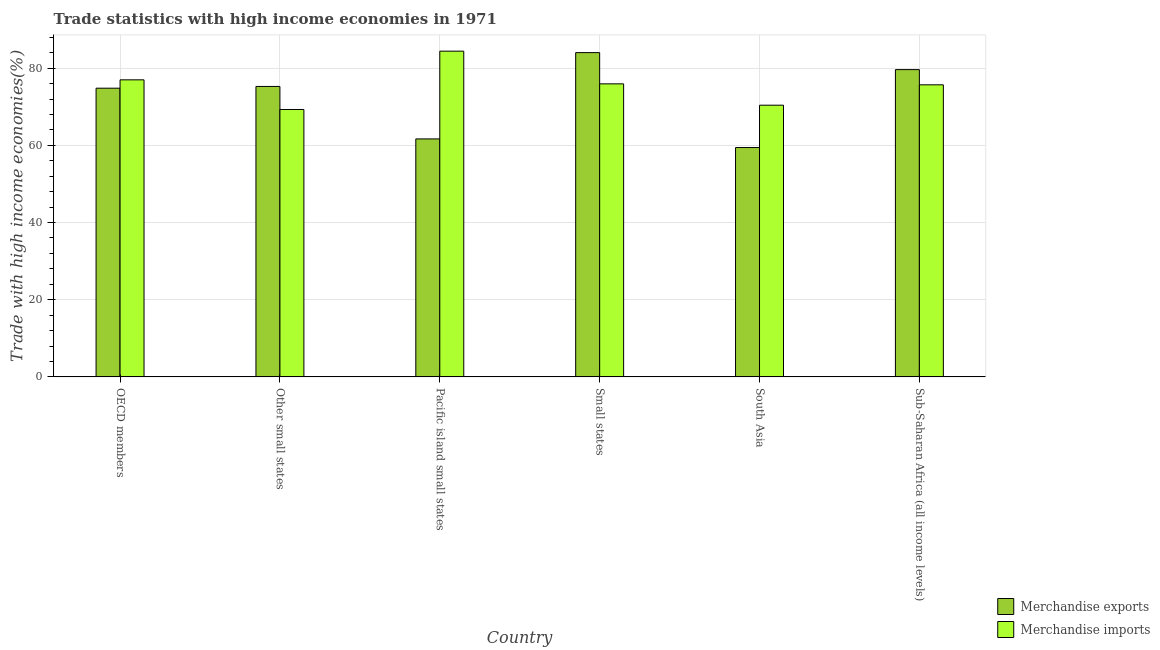Are the number of bars per tick equal to the number of legend labels?
Provide a succinct answer. Yes. Are the number of bars on each tick of the X-axis equal?
Provide a short and direct response. Yes. How many bars are there on the 4th tick from the left?
Make the answer very short. 2. What is the label of the 2nd group of bars from the left?
Offer a terse response. Other small states. In how many cases, is the number of bars for a given country not equal to the number of legend labels?
Offer a very short reply. 0. What is the merchandise exports in Other small states?
Provide a short and direct response. 75.28. Across all countries, what is the maximum merchandise imports?
Offer a very short reply. 84.42. Across all countries, what is the minimum merchandise imports?
Provide a succinct answer. 69.3. In which country was the merchandise imports maximum?
Offer a terse response. Pacific island small states. In which country was the merchandise imports minimum?
Provide a short and direct response. Other small states. What is the total merchandise exports in the graph?
Offer a very short reply. 434.9. What is the difference between the merchandise imports in OECD members and that in Other small states?
Provide a short and direct response. 7.69. What is the difference between the merchandise exports in Sub-Saharan Africa (all income levels) and the merchandise imports in Small states?
Offer a very short reply. 3.69. What is the average merchandise exports per country?
Give a very brief answer. 72.48. What is the difference between the merchandise exports and merchandise imports in Small states?
Provide a short and direct response. 8.1. In how many countries, is the merchandise imports greater than 52 %?
Give a very brief answer. 6. What is the ratio of the merchandise exports in Pacific island small states to that in South Asia?
Give a very brief answer. 1.04. Is the difference between the merchandise imports in Other small states and Small states greater than the difference between the merchandise exports in Other small states and Small states?
Provide a short and direct response. Yes. What is the difference between the highest and the second highest merchandise exports?
Your answer should be very brief. 4.41. What is the difference between the highest and the lowest merchandise exports?
Keep it short and to the point. 24.6. In how many countries, is the merchandise imports greater than the average merchandise imports taken over all countries?
Keep it short and to the point. 4. What does the 1st bar from the left in OECD members represents?
Your answer should be compact. Merchandise exports. What does the 2nd bar from the right in Sub-Saharan Africa (all income levels) represents?
Make the answer very short. Merchandise exports. Are all the bars in the graph horizontal?
Your answer should be compact. No. How many countries are there in the graph?
Offer a very short reply. 6. Does the graph contain any zero values?
Your answer should be compact. No. What is the title of the graph?
Offer a terse response. Trade statistics with high income economies in 1971. Does "Techinal cooperation" appear as one of the legend labels in the graph?
Your response must be concise. No. What is the label or title of the X-axis?
Make the answer very short. Country. What is the label or title of the Y-axis?
Provide a succinct answer. Trade with high income economies(%). What is the Trade with high income economies(%) in Merchandise exports in OECD members?
Offer a very short reply. 74.82. What is the Trade with high income economies(%) in Merchandise imports in OECD members?
Your answer should be compact. 76.99. What is the Trade with high income economies(%) of Merchandise exports in Other small states?
Offer a very short reply. 75.28. What is the Trade with high income economies(%) of Merchandise imports in Other small states?
Keep it short and to the point. 69.3. What is the Trade with high income economies(%) in Merchandise exports in Pacific island small states?
Ensure brevity in your answer.  61.68. What is the Trade with high income economies(%) in Merchandise imports in Pacific island small states?
Your answer should be very brief. 84.42. What is the Trade with high income economies(%) in Merchandise exports in Small states?
Provide a succinct answer. 84.04. What is the Trade with high income economies(%) in Merchandise imports in Small states?
Give a very brief answer. 75.95. What is the Trade with high income economies(%) in Merchandise exports in South Asia?
Your response must be concise. 59.44. What is the Trade with high income economies(%) of Merchandise imports in South Asia?
Give a very brief answer. 70.42. What is the Trade with high income economies(%) of Merchandise exports in Sub-Saharan Africa (all income levels)?
Provide a short and direct response. 79.64. What is the Trade with high income economies(%) of Merchandise imports in Sub-Saharan Africa (all income levels)?
Keep it short and to the point. 75.7. Across all countries, what is the maximum Trade with high income economies(%) in Merchandise exports?
Ensure brevity in your answer.  84.04. Across all countries, what is the maximum Trade with high income economies(%) in Merchandise imports?
Make the answer very short. 84.42. Across all countries, what is the minimum Trade with high income economies(%) of Merchandise exports?
Your answer should be very brief. 59.44. Across all countries, what is the minimum Trade with high income economies(%) of Merchandise imports?
Offer a very short reply. 69.3. What is the total Trade with high income economies(%) of Merchandise exports in the graph?
Provide a short and direct response. 434.9. What is the total Trade with high income economies(%) of Merchandise imports in the graph?
Offer a very short reply. 452.77. What is the difference between the Trade with high income economies(%) of Merchandise exports in OECD members and that in Other small states?
Offer a terse response. -0.45. What is the difference between the Trade with high income economies(%) in Merchandise imports in OECD members and that in Other small states?
Your answer should be compact. 7.69. What is the difference between the Trade with high income economies(%) of Merchandise exports in OECD members and that in Pacific island small states?
Make the answer very short. 13.14. What is the difference between the Trade with high income economies(%) in Merchandise imports in OECD members and that in Pacific island small states?
Offer a terse response. -7.43. What is the difference between the Trade with high income economies(%) of Merchandise exports in OECD members and that in Small states?
Offer a very short reply. -9.22. What is the difference between the Trade with high income economies(%) of Merchandise imports in OECD members and that in Small states?
Offer a very short reply. 1.04. What is the difference between the Trade with high income economies(%) in Merchandise exports in OECD members and that in South Asia?
Provide a succinct answer. 15.38. What is the difference between the Trade with high income economies(%) of Merchandise imports in OECD members and that in South Asia?
Provide a succinct answer. 6.57. What is the difference between the Trade with high income economies(%) in Merchandise exports in OECD members and that in Sub-Saharan Africa (all income levels)?
Your response must be concise. -4.81. What is the difference between the Trade with high income economies(%) in Merchandise imports in OECD members and that in Sub-Saharan Africa (all income levels)?
Your answer should be compact. 1.29. What is the difference between the Trade with high income economies(%) of Merchandise exports in Other small states and that in Pacific island small states?
Make the answer very short. 13.6. What is the difference between the Trade with high income economies(%) in Merchandise imports in Other small states and that in Pacific island small states?
Ensure brevity in your answer.  -15.12. What is the difference between the Trade with high income economies(%) in Merchandise exports in Other small states and that in Small states?
Your answer should be compact. -8.77. What is the difference between the Trade with high income economies(%) of Merchandise imports in Other small states and that in Small states?
Offer a terse response. -6.64. What is the difference between the Trade with high income economies(%) in Merchandise exports in Other small states and that in South Asia?
Provide a short and direct response. 15.83. What is the difference between the Trade with high income economies(%) in Merchandise imports in Other small states and that in South Asia?
Your response must be concise. -1.11. What is the difference between the Trade with high income economies(%) of Merchandise exports in Other small states and that in Sub-Saharan Africa (all income levels)?
Offer a very short reply. -4.36. What is the difference between the Trade with high income economies(%) of Merchandise imports in Other small states and that in Sub-Saharan Africa (all income levels)?
Offer a terse response. -6.4. What is the difference between the Trade with high income economies(%) in Merchandise exports in Pacific island small states and that in Small states?
Provide a short and direct response. -22.37. What is the difference between the Trade with high income economies(%) of Merchandise imports in Pacific island small states and that in Small states?
Provide a succinct answer. 8.48. What is the difference between the Trade with high income economies(%) in Merchandise exports in Pacific island small states and that in South Asia?
Offer a terse response. 2.24. What is the difference between the Trade with high income economies(%) in Merchandise imports in Pacific island small states and that in South Asia?
Your answer should be very brief. 14. What is the difference between the Trade with high income economies(%) in Merchandise exports in Pacific island small states and that in Sub-Saharan Africa (all income levels)?
Offer a very short reply. -17.96. What is the difference between the Trade with high income economies(%) in Merchandise imports in Pacific island small states and that in Sub-Saharan Africa (all income levels)?
Provide a succinct answer. 8.72. What is the difference between the Trade with high income economies(%) of Merchandise exports in Small states and that in South Asia?
Your answer should be very brief. 24.6. What is the difference between the Trade with high income economies(%) of Merchandise imports in Small states and that in South Asia?
Provide a short and direct response. 5.53. What is the difference between the Trade with high income economies(%) in Merchandise exports in Small states and that in Sub-Saharan Africa (all income levels)?
Offer a terse response. 4.41. What is the difference between the Trade with high income economies(%) of Merchandise imports in Small states and that in Sub-Saharan Africa (all income levels)?
Provide a short and direct response. 0.25. What is the difference between the Trade with high income economies(%) of Merchandise exports in South Asia and that in Sub-Saharan Africa (all income levels)?
Give a very brief answer. -20.19. What is the difference between the Trade with high income economies(%) of Merchandise imports in South Asia and that in Sub-Saharan Africa (all income levels)?
Offer a very short reply. -5.28. What is the difference between the Trade with high income economies(%) of Merchandise exports in OECD members and the Trade with high income economies(%) of Merchandise imports in Other small states?
Ensure brevity in your answer.  5.52. What is the difference between the Trade with high income economies(%) of Merchandise exports in OECD members and the Trade with high income economies(%) of Merchandise imports in Pacific island small states?
Make the answer very short. -9.6. What is the difference between the Trade with high income economies(%) of Merchandise exports in OECD members and the Trade with high income economies(%) of Merchandise imports in Small states?
Keep it short and to the point. -1.12. What is the difference between the Trade with high income economies(%) in Merchandise exports in OECD members and the Trade with high income economies(%) in Merchandise imports in South Asia?
Your answer should be compact. 4.41. What is the difference between the Trade with high income economies(%) of Merchandise exports in OECD members and the Trade with high income economies(%) of Merchandise imports in Sub-Saharan Africa (all income levels)?
Provide a succinct answer. -0.87. What is the difference between the Trade with high income economies(%) of Merchandise exports in Other small states and the Trade with high income economies(%) of Merchandise imports in Pacific island small states?
Provide a succinct answer. -9.15. What is the difference between the Trade with high income economies(%) in Merchandise exports in Other small states and the Trade with high income economies(%) in Merchandise imports in Small states?
Ensure brevity in your answer.  -0.67. What is the difference between the Trade with high income economies(%) of Merchandise exports in Other small states and the Trade with high income economies(%) of Merchandise imports in South Asia?
Your response must be concise. 4.86. What is the difference between the Trade with high income economies(%) in Merchandise exports in Other small states and the Trade with high income economies(%) in Merchandise imports in Sub-Saharan Africa (all income levels)?
Offer a very short reply. -0.42. What is the difference between the Trade with high income economies(%) in Merchandise exports in Pacific island small states and the Trade with high income economies(%) in Merchandise imports in Small states?
Offer a terse response. -14.27. What is the difference between the Trade with high income economies(%) in Merchandise exports in Pacific island small states and the Trade with high income economies(%) in Merchandise imports in South Asia?
Provide a succinct answer. -8.74. What is the difference between the Trade with high income economies(%) of Merchandise exports in Pacific island small states and the Trade with high income economies(%) of Merchandise imports in Sub-Saharan Africa (all income levels)?
Keep it short and to the point. -14.02. What is the difference between the Trade with high income economies(%) in Merchandise exports in Small states and the Trade with high income economies(%) in Merchandise imports in South Asia?
Your answer should be compact. 13.63. What is the difference between the Trade with high income economies(%) of Merchandise exports in Small states and the Trade with high income economies(%) of Merchandise imports in Sub-Saharan Africa (all income levels)?
Keep it short and to the point. 8.35. What is the difference between the Trade with high income economies(%) in Merchandise exports in South Asia and the Trade with high income economies(%) in Merchandise imports in Sub-Saharan Africa (all income levels)?
Keep it short and to the point. -16.26. What is the average Trade with high income economies(%) of Merchandise exports per country?
Make the answer very short. 72.48. What is the average Trade with high income economies(%) in Merchandise imports per country?
Ensure brevity in your answer.  75.46. What is the difference between the Trade with high income economies(%) of Merchandise exports and Trade with high income economies(%) of Merchandise imports in OECD members?
Keep it short and to the point. -2.16. What is the difference between the Trade with high income economies(%) of Merchandise exports and Trade with high income economies(%) of Merchandise imports in Other small states?
Make the answer very short. 5.97. What is the difference between the Trade with high income economies(%) in Merchandise exports and Trade with high income economies(%) in Merchandise imports in Pacific island small states?
Your answer should be very brief. -22.74. What is the difference between the Trade with high income economies(%) in Merchandise exports and Trade with high income economies(%) in Merchandise imports in Small states?
Ensure brevity in your answer.  8.1. What is the difference between the Trade with high income economies(%) in Merchandise exports and Trade with high income economies(%) in Merchandise imports in South Asia?
Give a very brief answer. -10.97. What is the difference between the Trade with high income economies(%) of Merchandise exports and Trade with high income economies(%) of Merchandise imports in Sub-Saharan Africa (all income levels)?
Keep it short and to the point. 3.94. What is the ratio of the Trade with high income economies(%) in Merchandise imports in OECD members to that in Other small states?
Offer a very short reply. 1.11. What is the ratio of the Trade with high income economies(%) in Merchandise exports in OECD members to that in Pacific island small states?
Keep it short and to the point. 1.21. What is the ratio of the Trade with high income economies(%) of Merchandise imports in OECD members to that in Pacific island small states?
Provide a short and direct response. 0.91. What is the ratio of the Trade with high income economies(%) in Merchandise exports in OECD members to that in Small states?
Offer a terse response. 0.89. What is the ratio of the Trade with high income economies(%) of Merchandise imports in OECD members to that in Small states?
Give a very brief answer. 1.01. What is the ratio of the Trade with high income economies(%) in Merchandise exports in OECD members to that in South Asia?
Your response must be concise. 1.26. What is the ratio of the Trade with high income economies(%) of Merchandise imports in OECD members to that in South Asia?
Make the answer very short. 1.09. What is the ratio of the Trade with high income economies(%) in Merchandise exports in OECD members to that in Sub-Saharan Africa (all income levels)?
Offer a very short reply. 0.94. What is the ratio of the Trade with high income economies(%) in Merchandise exports in Other small states to that in Pacific island small states?
Offer a very short reply. 1.22. What is the ratio of the Trade with high income economies(%) in Merchandise imports in Other small states to that in Pacific island small states?
Your answer should be compact. 0.82. What is the ratio of the Trade with high income economies(%) in Merchandise exports in Other small states to that in Small states?
Provide a short and direct response. 0.9. What is the ratio of the Trade with high income economies(%) in Merchandise imports in Other small states to that in Small states?
Provide a short and direct response. 0.91. What is the ratio of the Trade with high income economies(%) in Merchandise exports in Other small states to that in South Asia?
Your answer should be compact. 1.27. What is the ratio of the Trade with high income economies(%) in Merchandise imports in Other small states to that in South Asia?
Keep it short and to the point. 0.98. What is the ratio of the Trade with high income economies(%) in Merchandise exports in Other small states to that in Sub-Saharan Africa (all income levels)?
Your answer should be compact. 0.95. What is the ratio of the Trade with high income economies(%) in Merchandise imports in Other small states to that in Sub-Saharan Africa (all income levels)?
Your response must be concise. 0.92. What is the ratio of the Trade with high income economies(%) in Merchandise exports in Pacific island small states to that in Small states?
Your answer should be compact. 0.73. What is the ratio of the Trade with high income economies(%) of Merchandise imports in Pacific island small states to that in Small states?
Provide a short and direct response. 1.11. What is the ratio of the Trade with high income economies(%) of Merchandise exports in Pacific island small states to that in South Asia?
Your response must be concise. 1.04. What is the ratio of the Trade with high income economies(%) of Merchandise imports in Pacific island small states to that in South Asia?
Ensure brevity in your answer.  1.2. What is the ratio of the Trade with high income economies(%) in Merchandise exports in Pacific island small states to that in Sub-Saharan Africa (all income levels)?
Make the answer very short. 0.77. What is the ratio of the Trade with high income economies(%) of Merchandise imports in Pacific island small states to that in Sub-Saharan Africa (all income levels)?
Offer a terse response. 1.12. What is the ratio of the Trade with high income economies(%) of Merchandise exports in Small states to that in South Asia?
Keep it short and to the point. 1.41. What is the ratio of the Trade with high income economies(%) of Merchandise imports in Small states to that in South Asia?
Provide a short and direct response. 1.08. What is the ratio of the Trade with high income economies(%) in Merchandise exports in Small states to that in Sub-Saharan Africa (all income levels)?
Offer a terse response. 1.06. What is the ratio of the Trade with high income economies(%) in Merchandise imports in Small states to that in Sub-Saharan Africa (all income levels)?
Your response must be concise. 1. What is the ratio of the Trade with high income economies(%) in Merchandise exports in South Asia to that in Sub-Saharan Africa (all income levels)?
Offer a very short reply. 0.75. What is the ratio of the Trade with high income economies(%) in Merchandise imports in South Asia to that in Sub-Saharan Africa (all income levels)?
Your answer should be very brief. 0.93. What is the difference between the highest and the second highest Trade with high income economies(%) in Merchandise exports?
Offer a terse response. 4.41. What is the difference between the highest and the second highest Trade with high income economies(%) of Merchandise imports?
Your answer should be very brief. 7.43. What is the difference between the highest and the lowest Trade with high income economies(%) in Merchandise exports?
Make the answer very short. 24.6. What is the difference between the highest and the lowest Trade with high income economies(%) of Merchandise imports?
Your answer should be very brief. 15.12. 